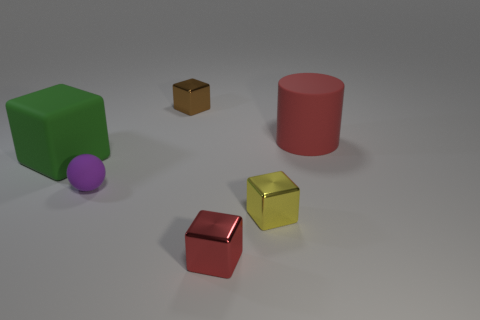Add 2 yellow objects. How many objects exist? 8 Subtract all cubes. How many objects are left? 2 Subtract all yellow things. Subtract all tiny objects. How many objects are left? 1 Add 1 green rubber things. How many green rubber things are left? 2 Add 1 red rubber objects. How many red rubber objects exist? 2 Subtract 1 purple balls. How many objects are left? 5 